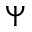Convert formula to latex. <formula><loc_0><loc_0><loc_500><loc_500>\boldsymbol \Psi</formula> 